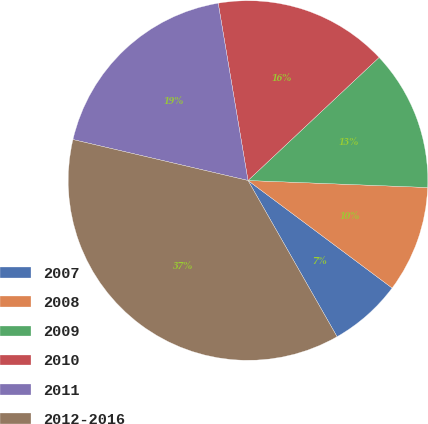<chart> <loc_0><loc_0><loc_500><loc_500><pie_chart><fcel>2007<fcel>2008<fcel>2009<fcel>2010<fcel>2011<fcel>2012-2016<nl><fcel>6.55%<fcel>9.58%<fcel>12.62%<fcel>15.65%<fcel>18.69%<fcel>36.9%<nl></chart> 